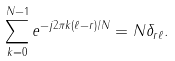Convert formula to latex. <formula><loc_0><loc_0><loc_500><loc_500>\sum _ { k = 0 } ^ { N - 1 } e ^ { - j 2 \pi k ( \ell - r ) / N } = N \delta _ { r \ell } .</formula> 